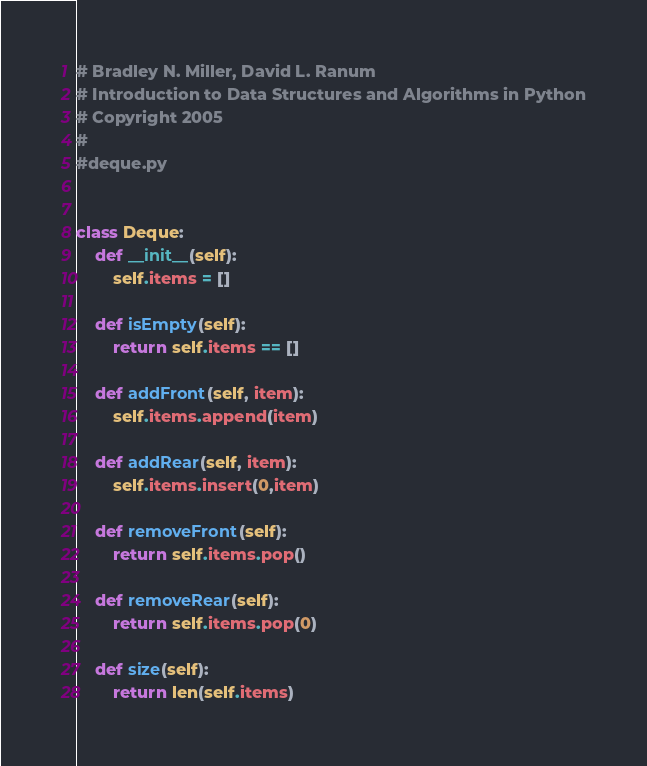Convert code to text. <code><loc_0><loc_0><loc_500><loc_500><_Python_># Bradley N. Miller, David L. Ranum
# Introduction to Data Structures and Algorithms in Python
# Copyright 2005
#
#deque.py


class Deque:
    def __init__(self):
        self.items = []

    def isEmpty(self):
        return self.items == []

    def addFront(self, item):
        self.items.append(item)

    def addRear(self, item):
        self.items.insert(0,item)

    def removeFront(self):
        return self.items.pop()

    def removeRear(self):
        return self.items.pop(0)

    def size(self):
        return len(self.items)
</code> 